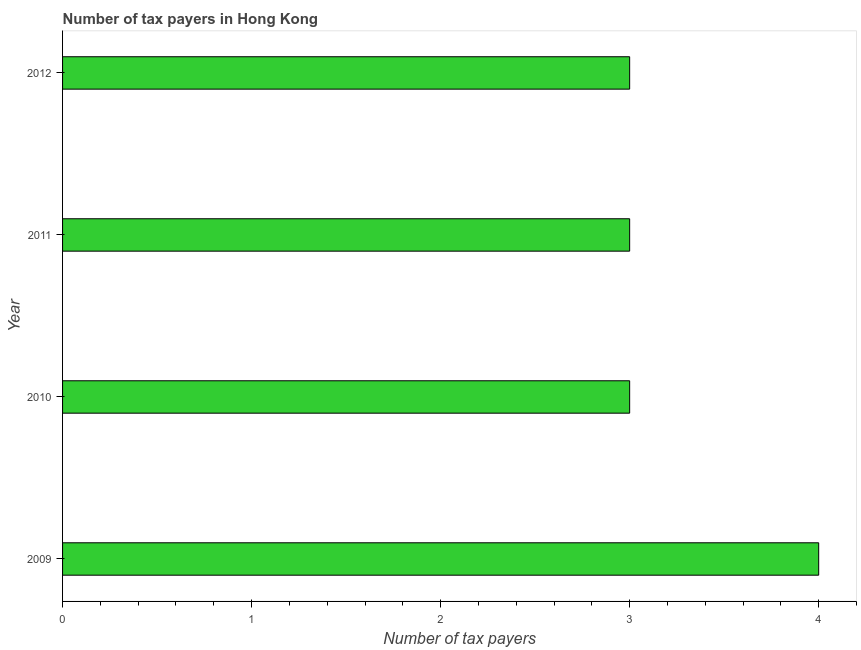Does the graph contain grids?
Provide a short and direct response. No. What is the title of the graph?
Make the answer very short. Number of tax payers in Hong Kong. What is the label or title of the X-axis?
Make the answer very short. Number of tax payers. What is the number of tax payers in 2009?
Keep it short and to the point. 4. Across all years, what is the maximum number of tax payers?
Offer a very short reply. 4. In which year was the number of tax payers maximum?
Ensure brevity in your answer.  2009. What is the sum of the number of tax payers?
Your answer should be compact. 13. What is the difference between the number of tax payers in 2009 and 2011?
Give a very brief answer. 1. What is the average number of tax payers per year?
Keep it short and to the point. 3. In how many years, is the number of tax payers greater than 3.4 ?
Make the answer very short. 1. What is the ratio of the number of tax payers in 2009 to that in 2011?
Your answer should be compact. 1.33. Is the number of tax payers in 2009 less than that in 2012?
Give a very brief answer. No. What is the difference between the highest and the second highest number of tax payers?
Your answer should be compact. 1. In how many years, is the number of tax payers greater than the average number of tax payers taken over all years?
Your response must be concise. 1. How many bars are there?
Make the answer very short. 4. How many years are there in the graph?
Keep it short and to the point. 4. What is the difference between two consecutive major ticks on the X-axis?
Provide a succinct answer. 1. Are the values on the major ticks of X-axis written in scientific E-notation?
Keep it short and to the point. No. What is the Number of tax payers of 2011?
Make the answer very short. 3. What is the Number of tax payers in 2012?
Your answer should be very brief. 3. What is the difference between the Number of tax payers in 2009 and 2010?
Offer a very short reply. 1. What is the difference between the Number of tax payers in 2010 and 2011?
Your answer should be very brief. 0. What is the difference between the Number of tax payers in 2010 and 2012?
Your answer should be very brief. 0. What is the difference between the Number of tax payers in 2011 and 2012?
Your answer should be compact. 0. What is the ratio of the Number of tax payers in 2009 to that in 2010?
Give a very brief answer. 1.33. What is the ratio of the Number of tax payers in 2009 to that in 2011?
Offer a terse response. 1.33. What is the ratio of the Number of tax payers in 2009 to that in 2012?
Ensure brevity in your answer.  1.33. What is the ratio of the Number of tax payers in 2010 to that in 2012?
Keep it short and to the point. 1. 